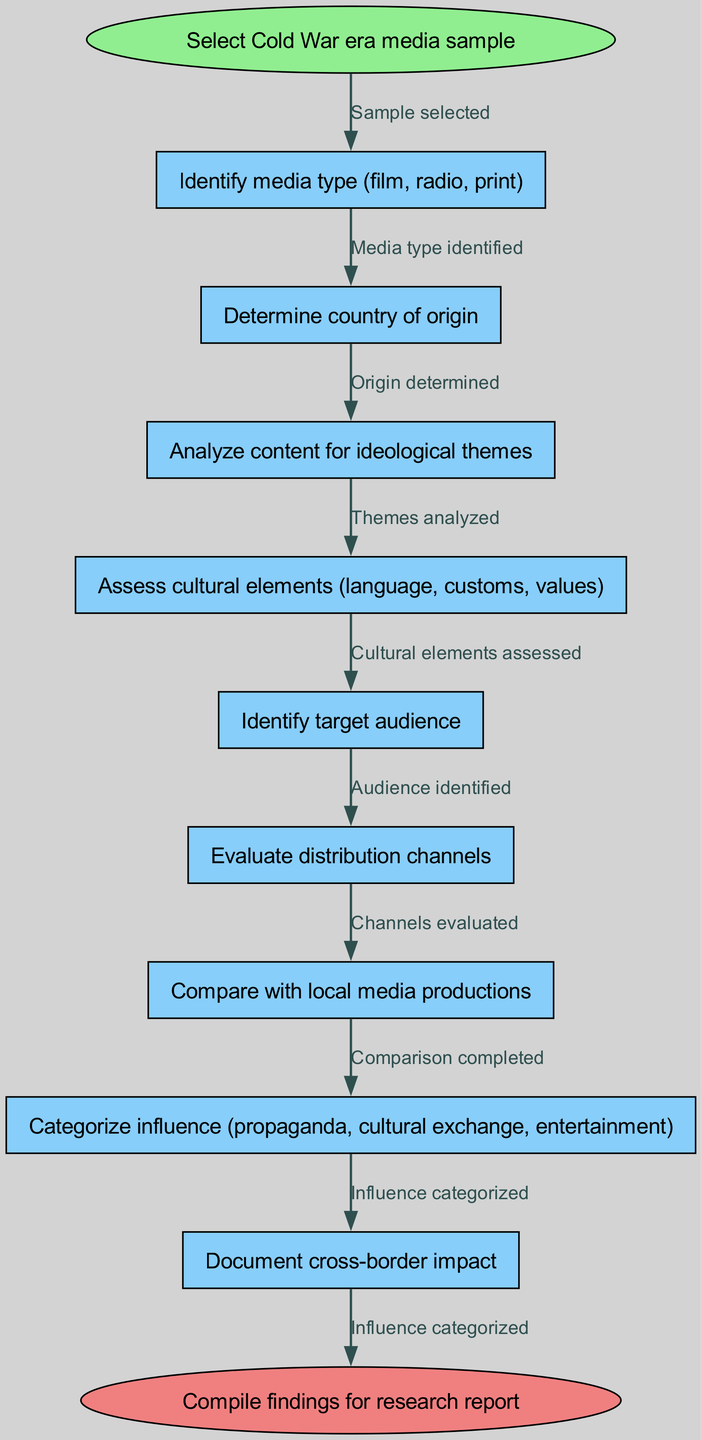What is the starting point of the diagram? The starting point of the diagram is explicitly indicated as "Select Cold War era media sample" in the start node.
Answer: Select Cold War era media sample How many process nodes are there in the flow chart? By counting the nodes listed in the provided nodes section, we find there are 8 process nodes that follow the starting point.
Answer: 8 What is the final action in the flow chart? The final action denoted in the end node specifies "Compile findings for research report." This is the last step after processing all previous nodes.
Answer: Compile findings for research report Which media type is identified first in the flow chart? The first identified media type in the flow chart is "Identify media type (film, radio, print)," which is the immediate next action after the starting point.
Answer: Identify media type (film, radio, print) What step follows after assessing cultural elements? The step that immediately follows "Assess cultural elements (language, customs, values)" is "Identify target audience." This indicates a sequential progression in the flow of the diagram.
Answer: Identify target audience How does the flow move from evaluating distribution channels to categorizing influence? After "Evaluate distribution channels," the subsequent flow moves directly to "Categorize influence (propaganda, cultural exchange, entertainment)," establishing a clear connection and order of assessment.
Answer: Categorize influence (propaganda, cultural exchange, entertainment) What does the flow chart compare local media productions with? The flow chart specifies that local media productions are compared with cross-border media influences, which is articulated in the node labeled "Compare with local media productions."
Answer: Cross-border media influences What influence categorization comes after comparing with local media productions? The influence categorization that follows that step is "Categorize influence (propaganda, cultural exchange, entertainment)," indicating the progression from comparison to classification.
Answer: Categorize influence (propaganda, cultural exchange, entertainment) How many edges connect the starting point to the first node? There is only one edge that connects the starting point to the first process node, labeled "Sample selected," indicating a singular transition from initiation to action.
Answer: 1 